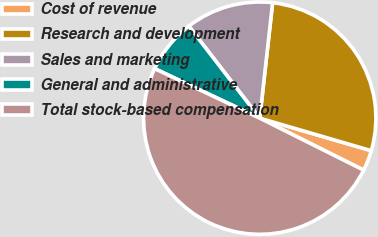Convert chart. <chart><loc_0><loc_0><loc_500><loc_500><pie_chart><fcel>Cost of revenue<fcel>Research and development<fcel>Sales and marketing<fcel>General and administrative<fcel>Total stock-based compensation<nl><fcel>2.86%<fcel>27.75%<fcel>12.22%<fcel>7.54%<fcel>49.63%<nl></chart> 